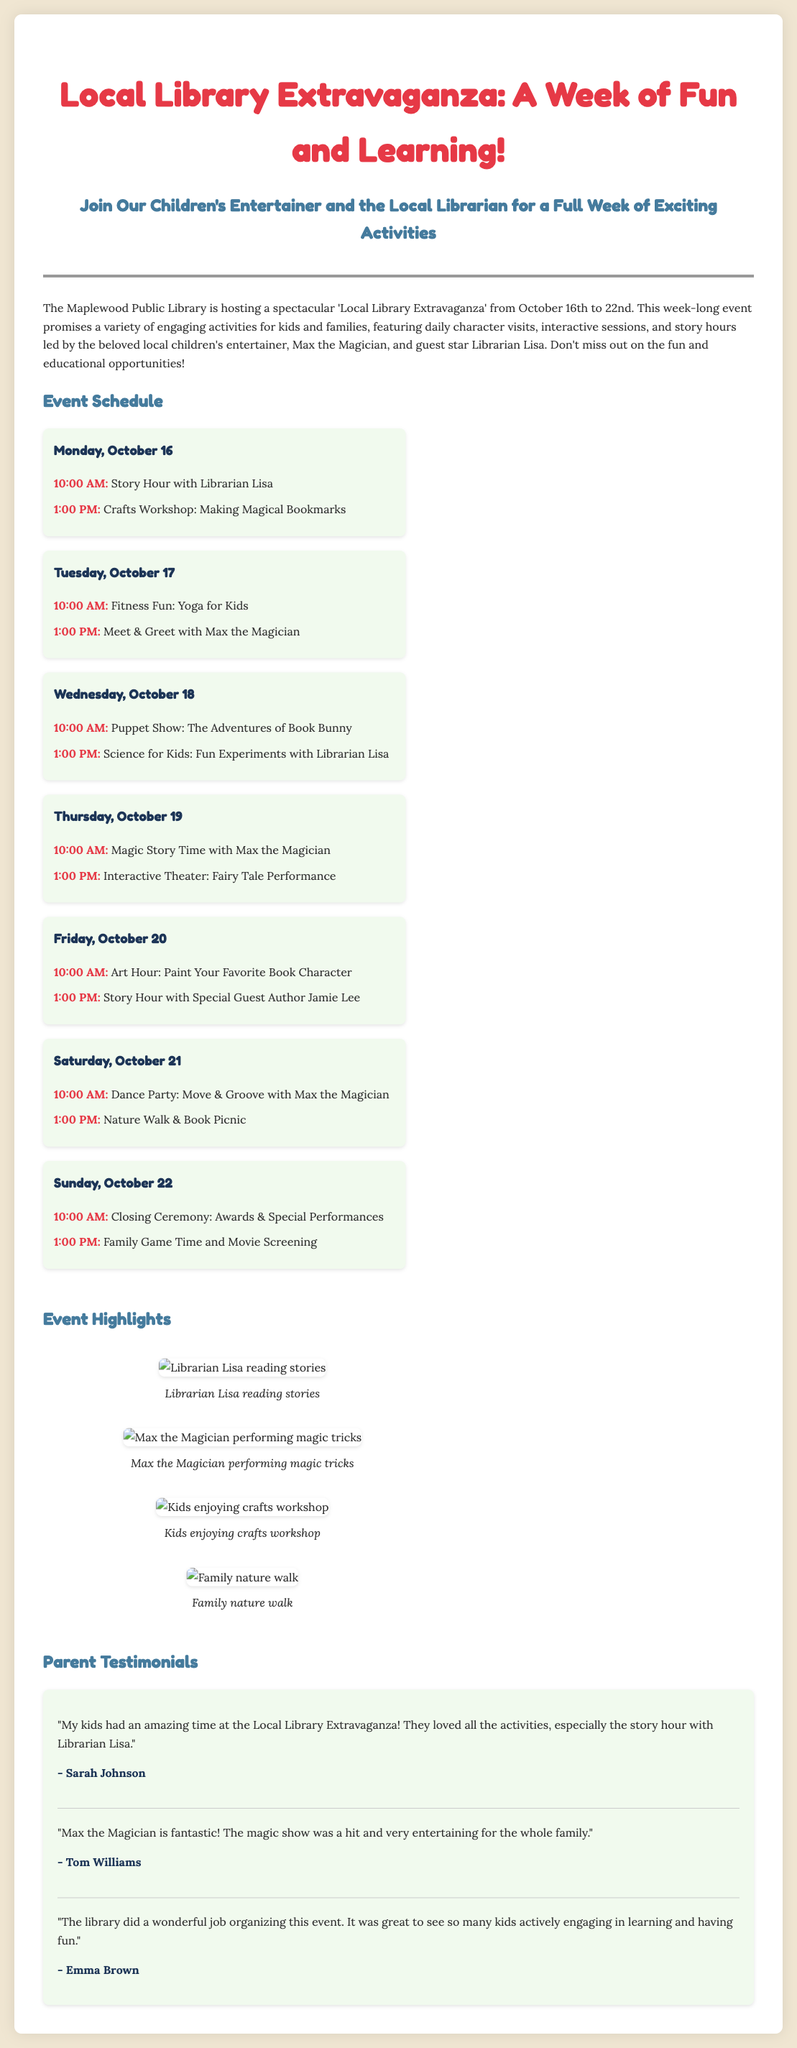What is the title of the event? The title of the event is clearly stated at the top of the document.
Answer: Local Library Extravaganza: A Week of Fun and Learning Who is the guest star at the event? The document mentions Librarian Lisa as the guest star in the event details.
Answer: Librarian Lisa What is scheduled for Tuesday, October 17 at 10:00 AM? The schedule lists the activities by day and time, specifically on Tuesday.
Answer: Fitness Fun: Yoga for Kids How many days does the event run? The start and end dates imply the event duration, which is calculated directly from the dates given.
Answer: 7 days What is the theme of the Arts Hour activity? The schedule provides specific activity details, including the theme of the Arts Hour.
Answer: Paint Your Favorite Book Character Which character visits the library on Thursday? Details in the document specify which character is involved in the activities on that particular day.
Answer: Max the Magician What feedback did Sarah Johnson provide? Parent testimonials section includes direct quotes from attendees about their experiences.
Answer: "My kids had an amazing time at the Local Library Extravaganza!" How many activities are planned for Sunday, October 22? The document lists the activities for each day, allowing for a count of the activities on Sunday.
Answer: 2 activities 